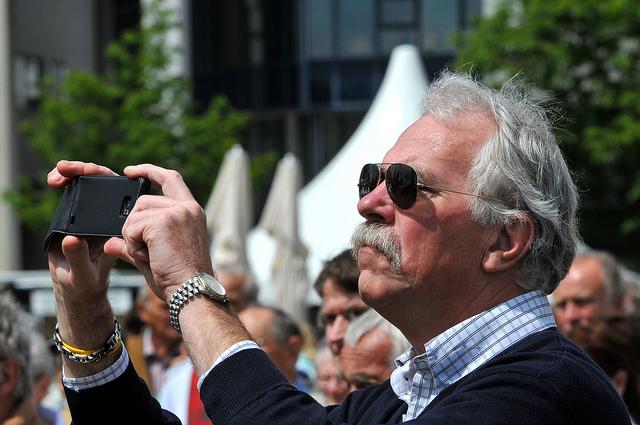Is it a sunny day?
Be succinct. Yes. Is he taking a picture?
Quick response, please. Yes. Is this man clean shaven?
Quick response, please. No. 